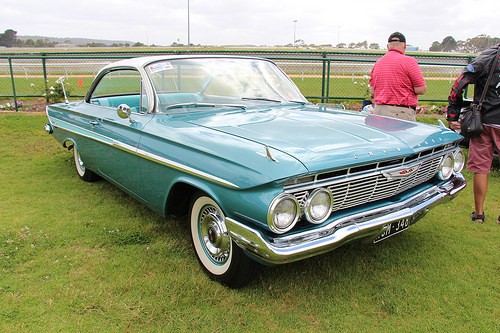<image>
Can you confirm if the car is on the road? No. The car is not positioned on the road. They may be near each other, but the car is not supported by or resting on top of the road. Is there a person behind the car? Yes. From this viewpoint, the person is positioned behind the car, with the car partially or fully occluding the person. Is there a man in the car? No. The man is not contained within the car. These objects have a different spatial relationship. 